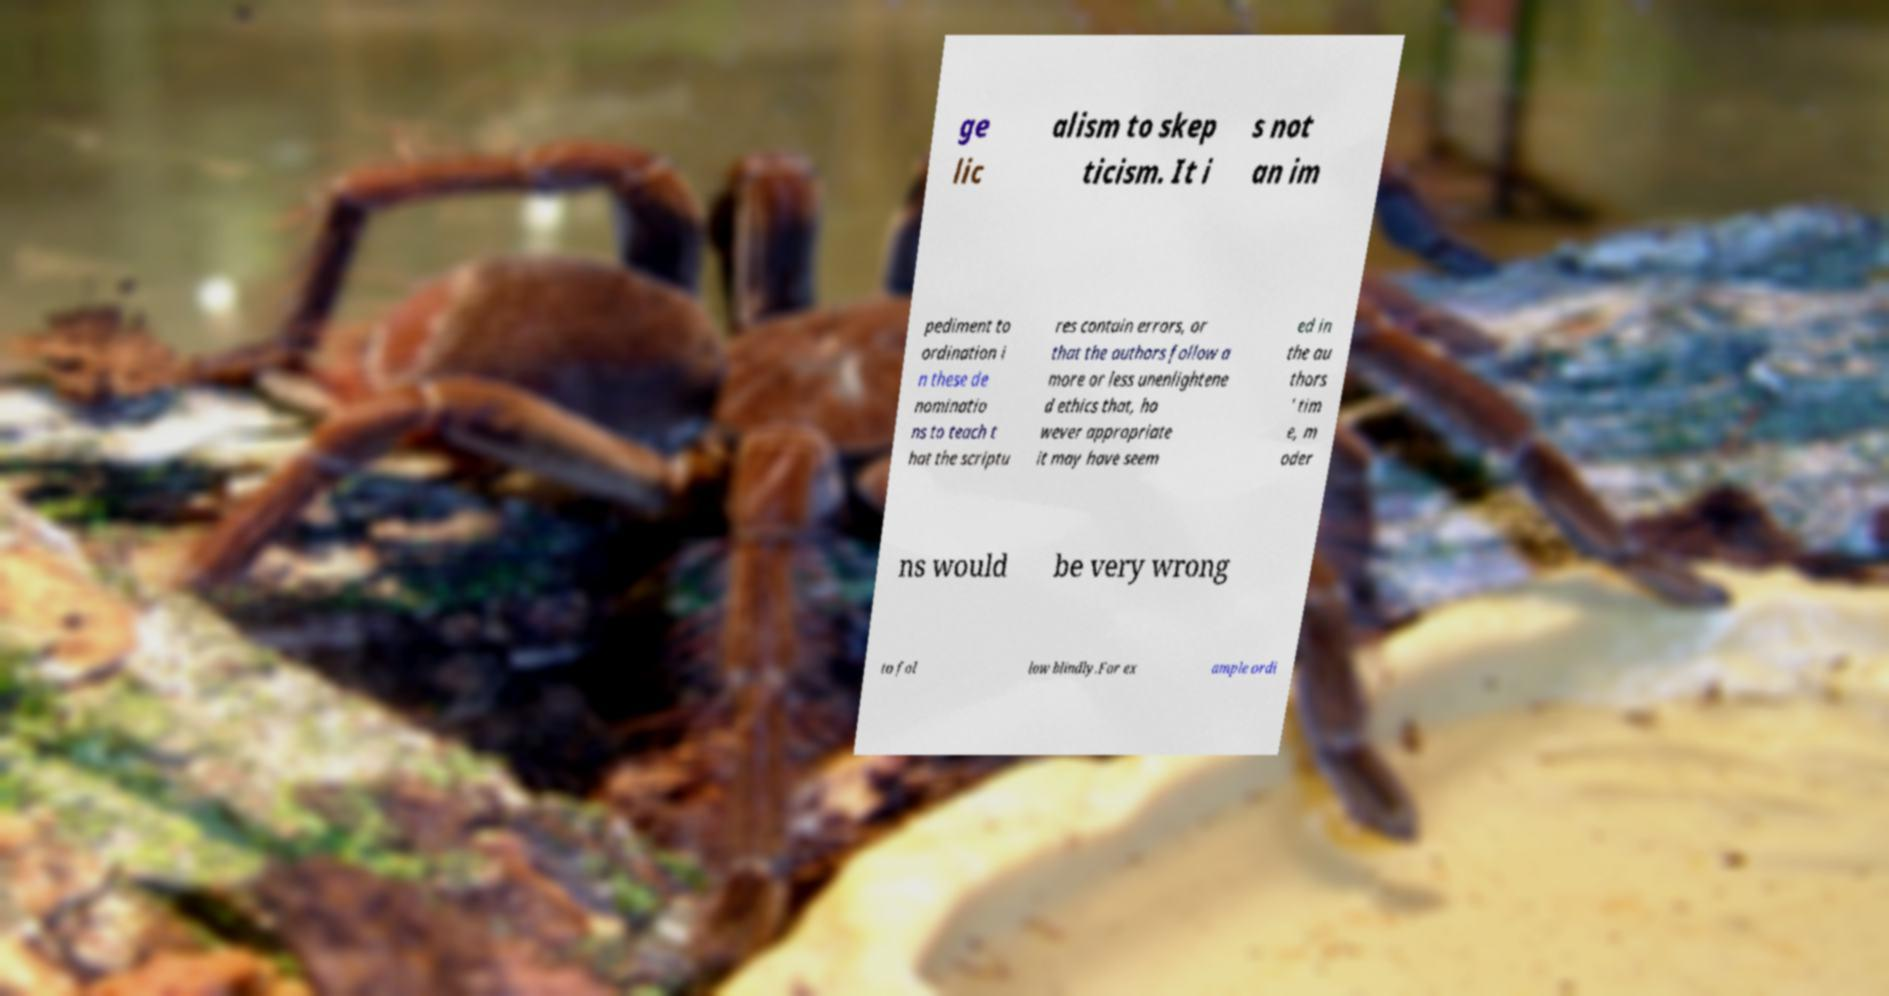Can you read and provide the text displayed in the image?This photo seems to have some interesting text. Can you extract and type it out for me? ge lic alism to skep ticism. It i s not an im pediment to ordination i n these de nominatio ns to teach t hat the scriptu res contain errors, or that the authors follow a more or less unenlightene d ethics that, ho wever appropriate it may have seem ed in the au thors ' tim e, m oder ns would be very wrong to fol low blindly.For ex ample ordi 